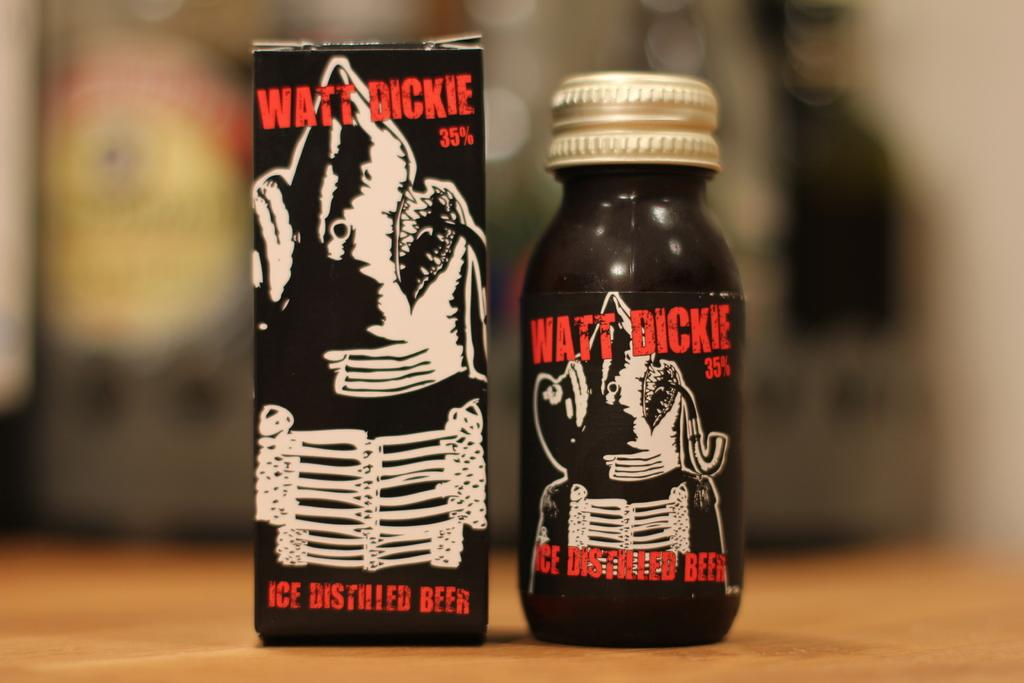Provide a one-sentence caption for the provided image. A package of distilled beer next to a bottle of the same beer. 